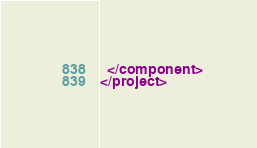<code> <loc_0><loc_0><loc_500><loc_500><_XML_>  </component>
</project></code> 